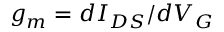<formula> <loc_0><loc_0><loc_500><loc_500>g _ { m } = d I _ { D S } / d V _ { G }</formula> 